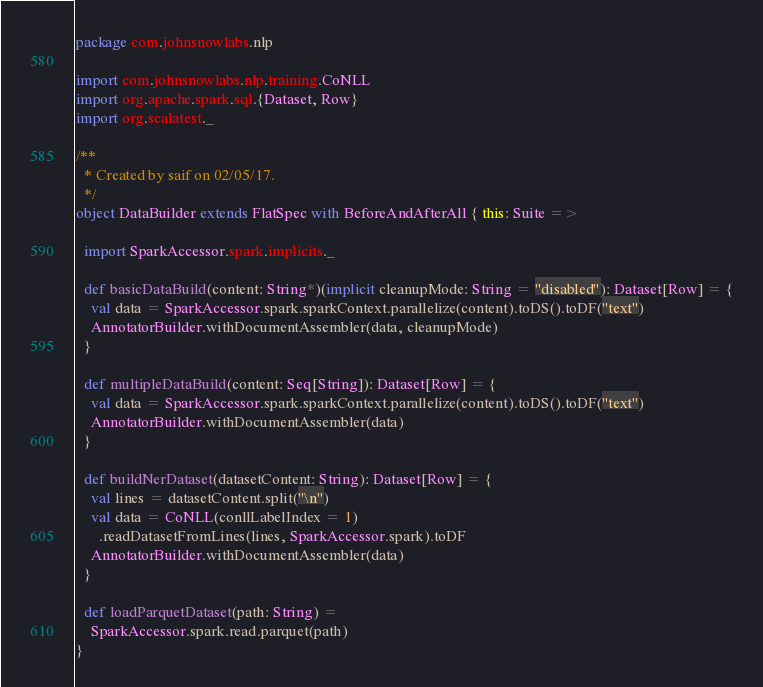Convert code to text. <code><loc_0><loc_0><loc_500><loc_500><_Scala_>package com.johnsnowlabs.nlp

import com.johnsnowlabs.nlp.training.CoNLL
import org.apache.spark.sql.{Dataset, Row}
import org.scalatest._

/**
  * Created by saif on 02/05/17.
  */
object DataBuilder extends FlatSpec with BeforeAndAfterAll { this: Suite =>

  import SparkAccessor.spark.implicits._

  def basicDataBuild(content: String*)(implicit cleanupMode: String = "disabled"): Dataset[Row] = {
    val data = SparkAccessor.spark.sparkContext.parallelize(content).toDS().toDF("text")
    AnnotatorBuilder.withDocumentAssembler(data, cleanupMode)
  }

  def multipleDataBuild(content: Seq[String]): Dataset[Row] = {
    val data = SparkAccessor.spark.sparkContext.parallelize(content).toDS().toDF("text")
    AnnotatorBuilder.withDocumentAssembler(data)
  }

  def buildNerDataset(datasetContent: String): Dataset[Row] = {
    val lines = datasetContent.split("\n")
    val data = CoNLL(conllLabelIndex = 1)
      .readDatasetFromLines(lines, SparkAccessor.spark).toDF
    AnnotatorBuilder.withDocumentAssembler(data)
  }

  def loadParquetDataset(path: String) =
    SparkAccessor.spark.read.parquet(path)
}
</code> 